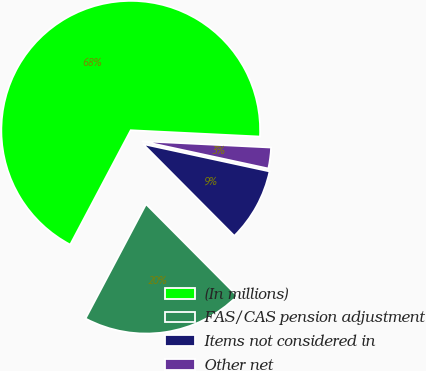Convert chart. <chart><loc_0><loc_0><loc_500><loc_500><pie_chart><fcel>(In millions)<fcel>FAS/CAS pension adjustment<fcel>Items not considered in<fcel>Other net<nl><fcel>68.03%<fcel>20.2%<fcel>9.16%<fcel>2.61%<nl></chart> 